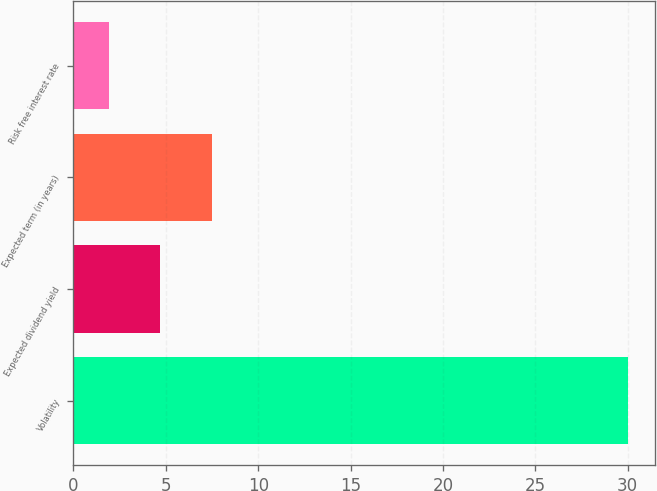<chart> <loc_0><loc_0><loc_500><loc_500><bar_chart><fcel>Volatility<fcel>Expected dividend yield<fcel>Expected term (in years)<fcel>Risk free interest rate<nl><fcel>30<fcel>4.71<fcel>7.52<fcel>1.9<nl></chart> 